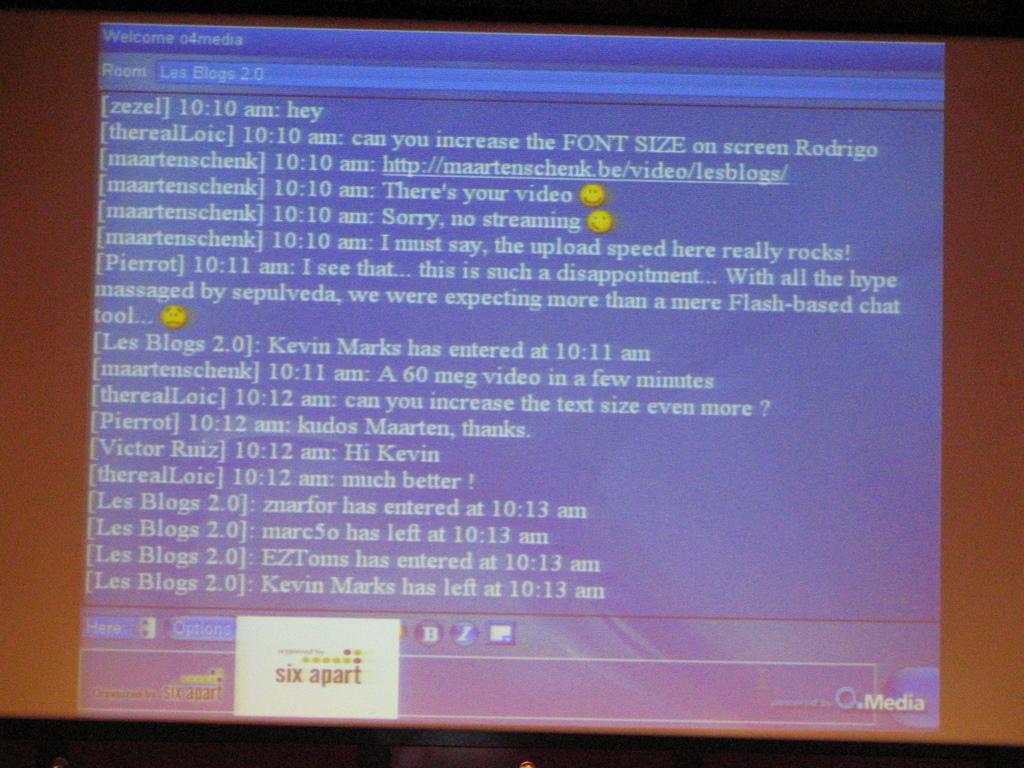What time did kevin marks enter the chat?
Give a very brief answer. 10:11 am. This is a computer program?
Offer a terse response. Yes. 